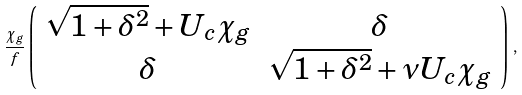<formula> <loc_0><loc_0><loc_500><loc_500>\frac { \chi _ { g } } { f } \left ( \begin{array} { c c c c } \sqrt { 1 + \delta ^ { 2 } } + U _ { c } \chi _ { g } & \delta \\ \delta & \sqrt { 1 + \delta ^ { 2 } } + \nu U _ { c } \chi _ { g } \end{array} \right ) \, ,</formula> 